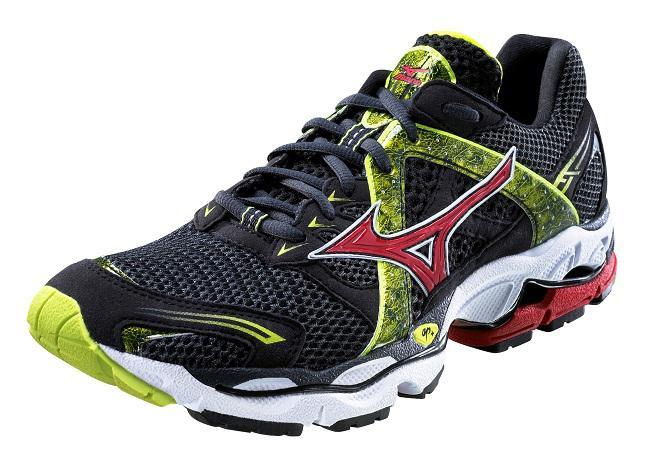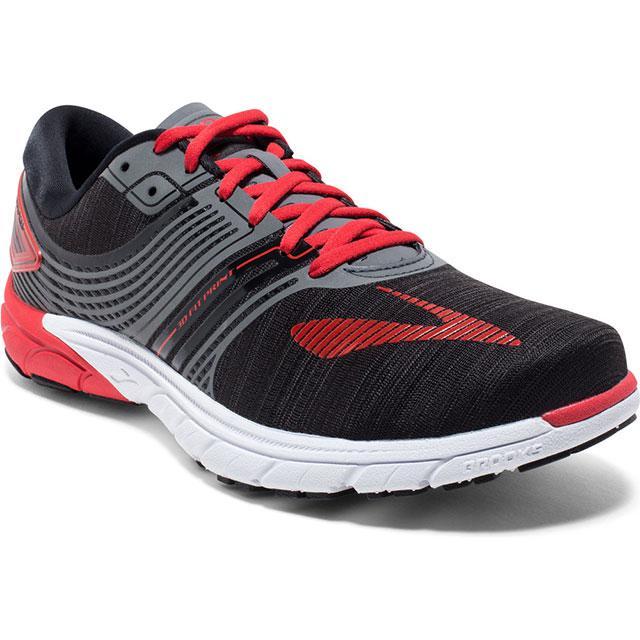The first image is the image on the left, the second image is the image on the right. For the images shown, is this caption "The shoe style in one image is black with pink and white accents, and tied with black laces with pink edging." true? Answer yes or no. No. The first image is the image on the left, the second image is the image on the right. For the images displayed, is the sentence "Each image contains exactly one athletic shoe shown at an angle." factually correct? Answer yes or no. Yes. 